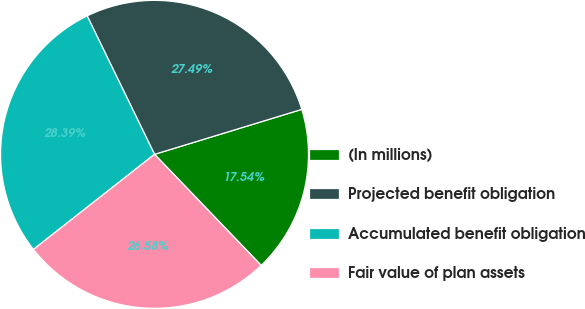<chart> <loc_0><loc_0><loc_500><loc_500><pie_chart><fcel>(In millions)<fcel>Projected benefit obligation<fcel>Accumulated benefit obligation<fcel>Fair value of plan assets<nl><fcel>17.54%<fcel>27.49%<fcel>28.39%<fcel>26.58%<nl></chart> 